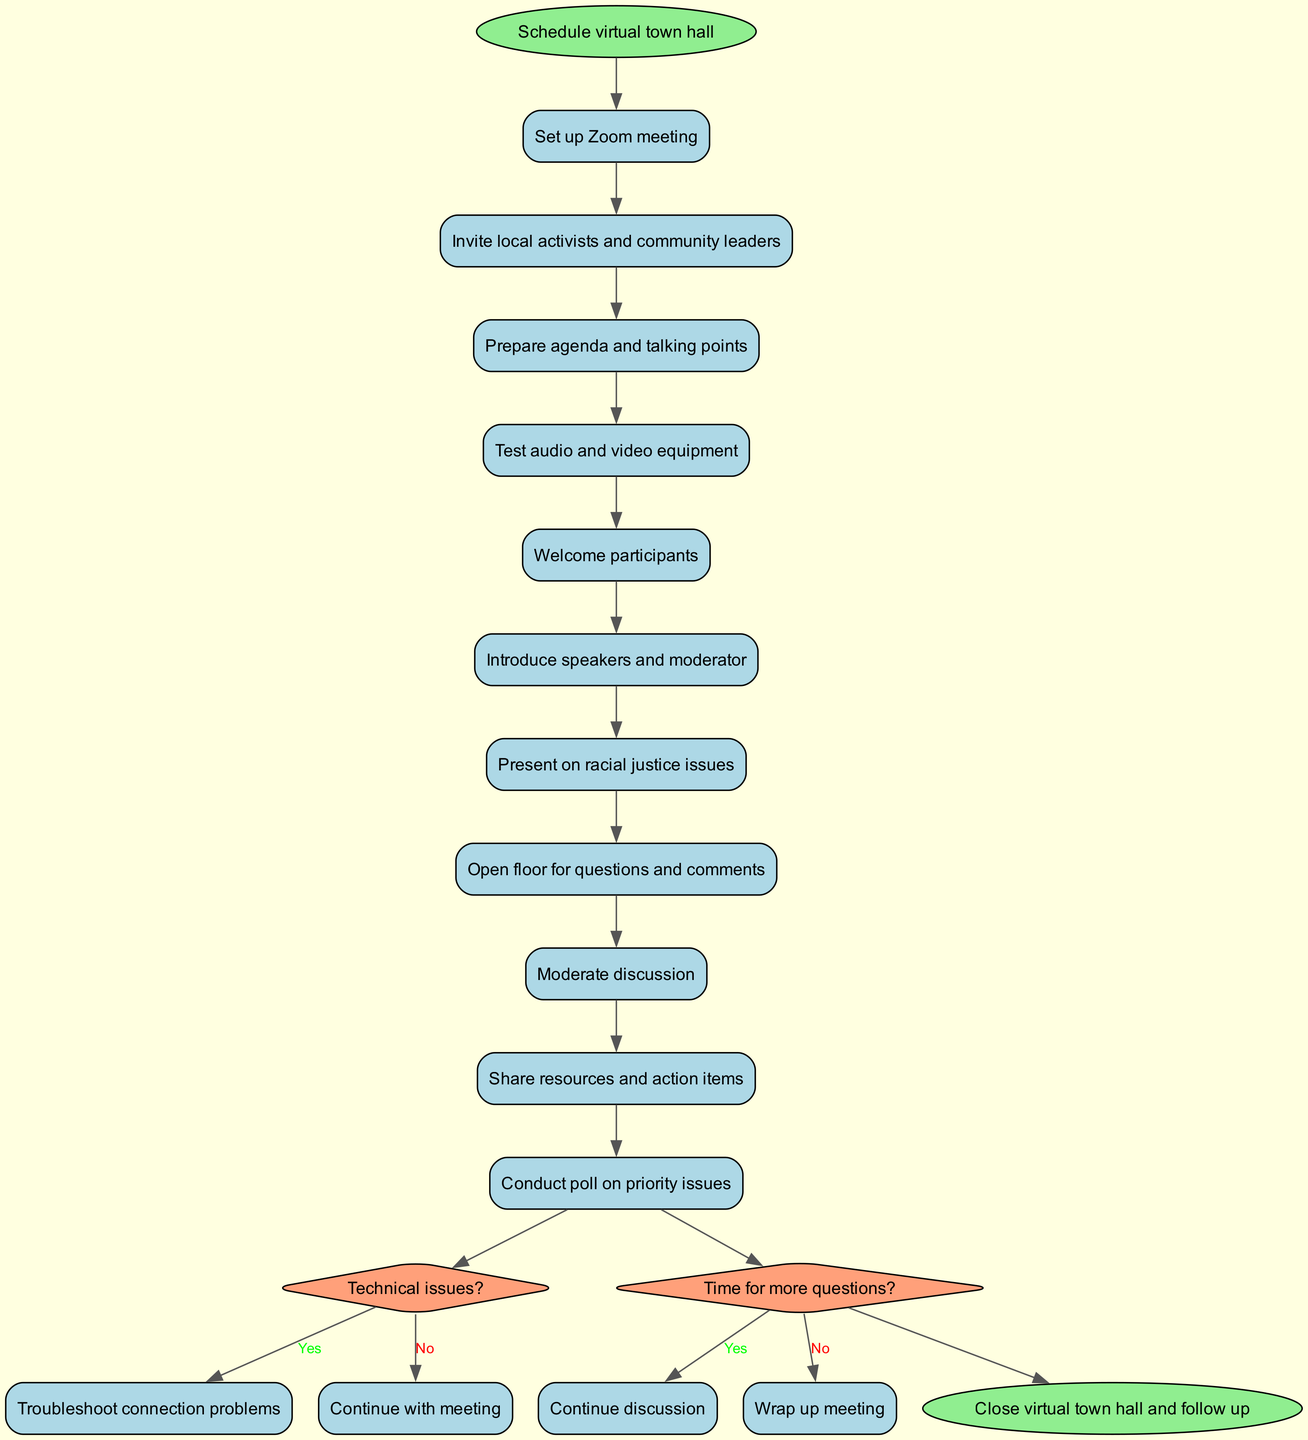What is the starting activity in the diagram? The starting node of the diagram is labeled “Schedule virtual town hall.” This is explicitly stated as the starting point of the entire process.
Answer: Schedule virtual town hall How many activities are there in total? The diagram lists 11 activities, which can be counted directly from the activities section in the diagram's data.
Answer: 11 What follows after "Welcome participants"? The flow indicates that after "Welcome participants," the next activity is "Introduce speakers and moderator." This can be traced by following the edges from one node to the next in the diagram.
Answer: Introduce speakers and moderator What happens if there are technical issues? If there are technical issues, the flow leads to the action "Troubleshoot connection problems." This is determined by following the decision point that asks if there are technical issues and observing the 'yes' branch.
Answer: Troubleshoot connection problems What is the last action before closing the town hall meeting? The final action before reaching the end node is "Conduct poll on priority issues." This can be found by following the activity flow up to before the end node.
Answer: Conduct poll on priority issues If the discussion continues after the questions, which activity follows? If there is time for more questions, the flow directs back to "Continue discussion," indicating a loop in the process based on participant interaction. Hence, the answer is found by following the decision point's 'yes' outcome.
Answer: Continue discussion How many decision points are there in the diagram? There are 2 decision points represented in the diagram. This is determined by counting the diamond shapes that indicate decision points in the activity flow.
Answer: 2 What is the final node in the diagram? The final node in the activity diagram is "Close virtual town hall and follow up." This endpoint can be identified as the last shape in the flow leading away from the last decision point.
Answer: Close virtual town hall and follow up What is the first decision point about? The first decision point asks, "Technical issues?" This can be seen by locating the first diamond shape in the diagram representing this decision.
Answer: Technical issues 